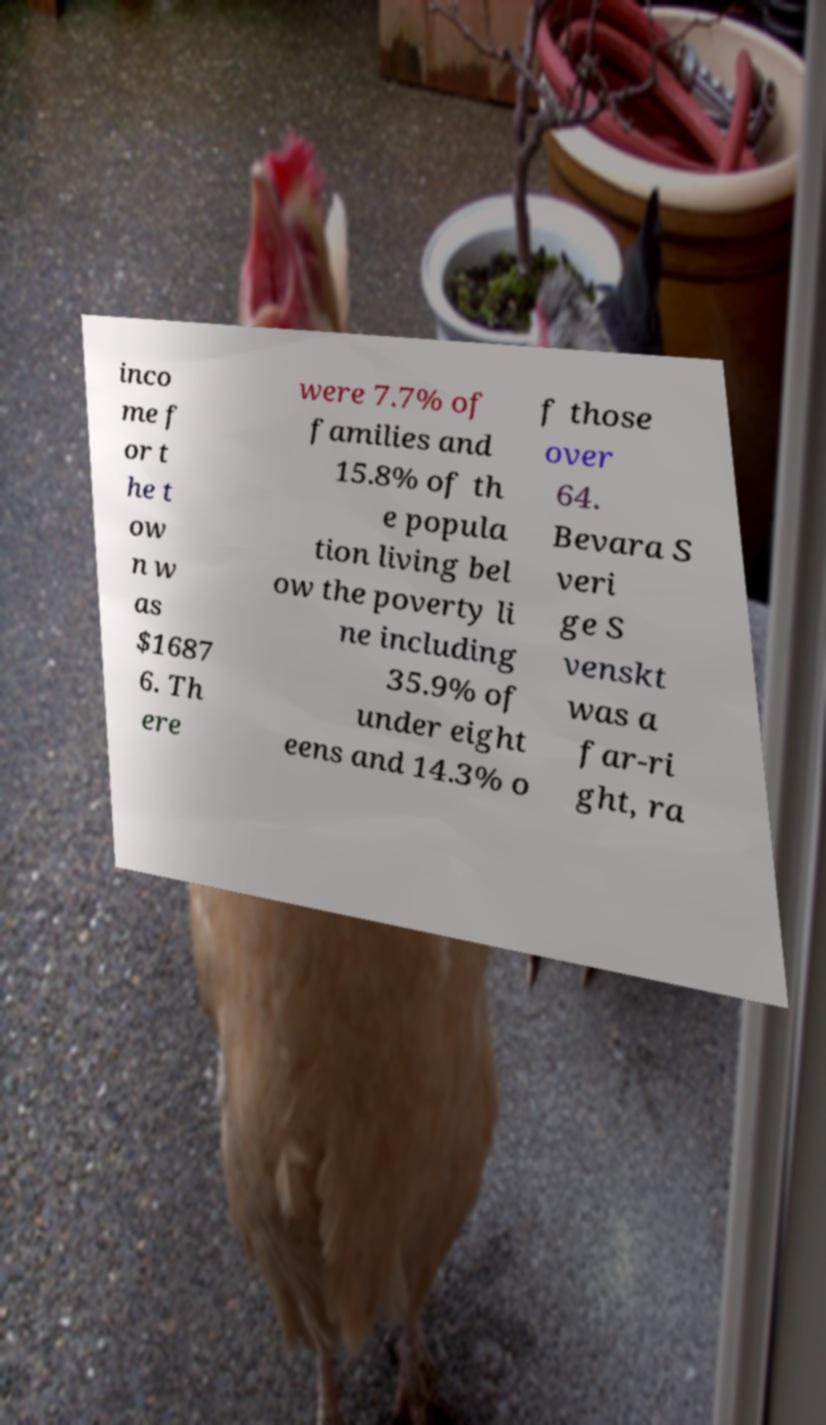Can you accurately transcribe the text from the provided image for me? inco me f or t he t ow n w as $1687 6. Th ere were 7.7% of families and 15.8% of th e popula tion living bel ow the poverty li ne including 35.9% of under eight eens and 14.3% o f those over 64. Bevara S veri ge S venskt was a far-ri ght, ra 